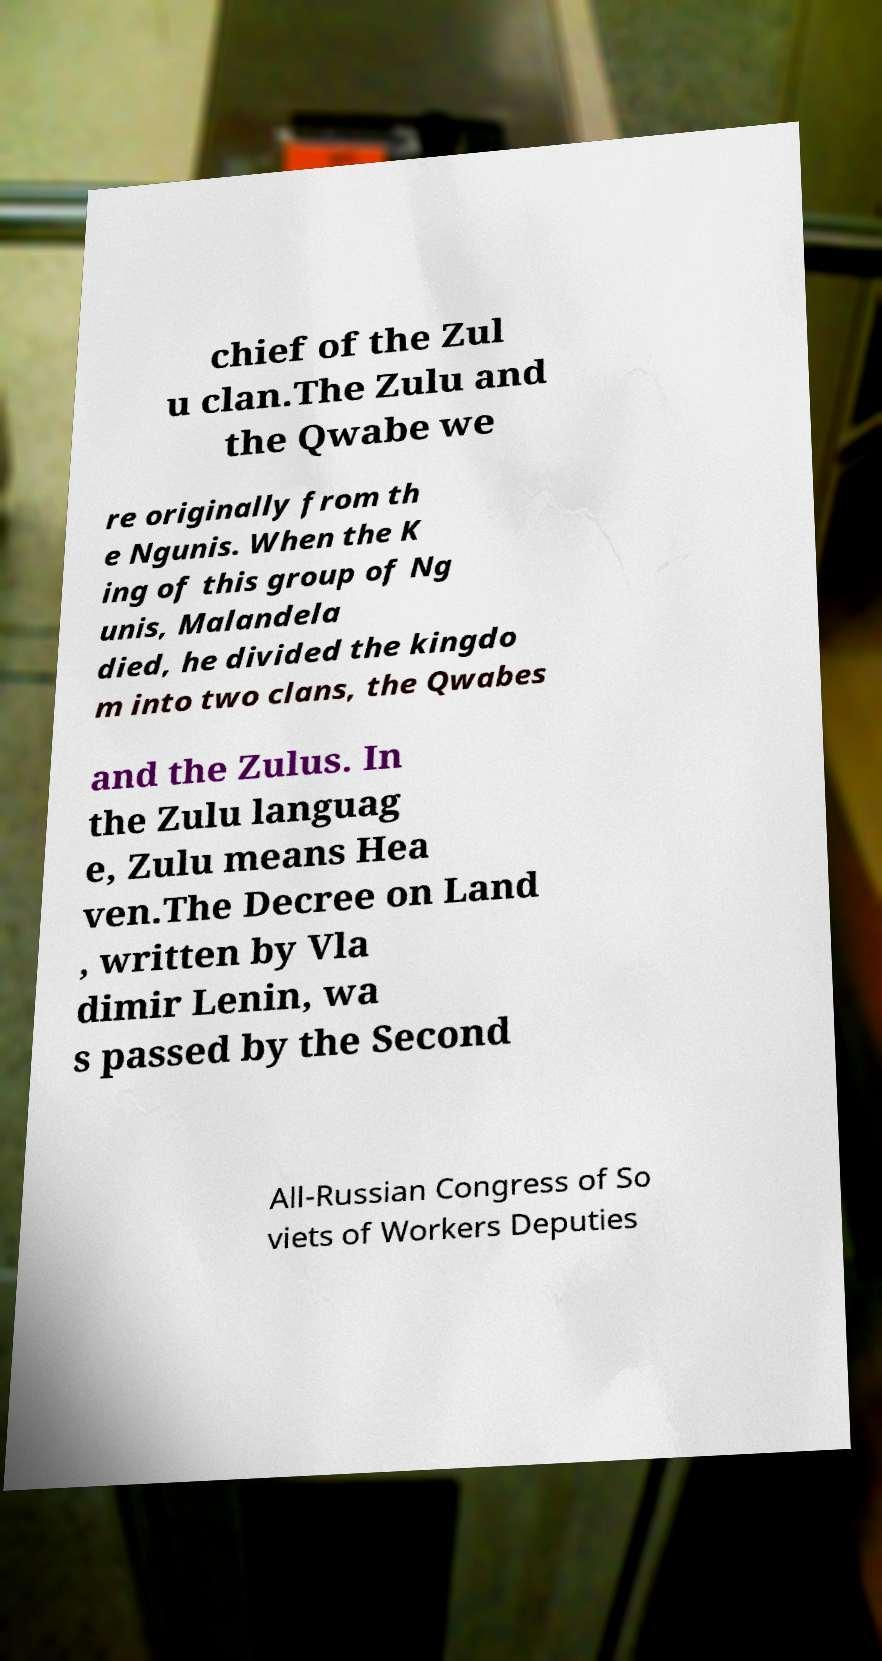What messages or text are displayed in this image? I need them in a readable, typed format. chief of the Zul u clan.The Zulu and the Qwabe we re originally from th e Ngunis. When the K ing of this group of Ng unis, Malandela died, he divided the kingdo m into two clans, the Qwabes and the Zulus. In the Zulu languag e, Zulu means Hea ven.The Decree on Land , written by Vla dimir Lenin, wa s passed by the Second All-Russian Congress of So viets of Workers Deputies 